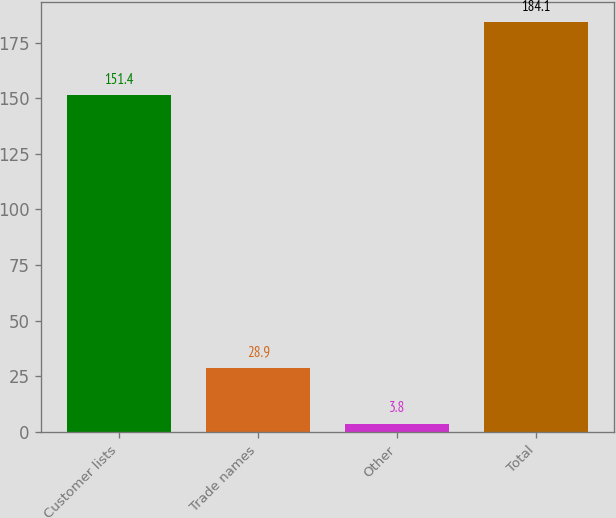Convert chart. <chart><loc_0><loc_0><loc_500><loc_500><bar_chart><fcel>Customer lists<fcel>Trade names<fcel>Other<fcel>Total<nl><fcel>151.4<fcel>28.9<fcel>3.8<fcel>184.1<nl></chart> 